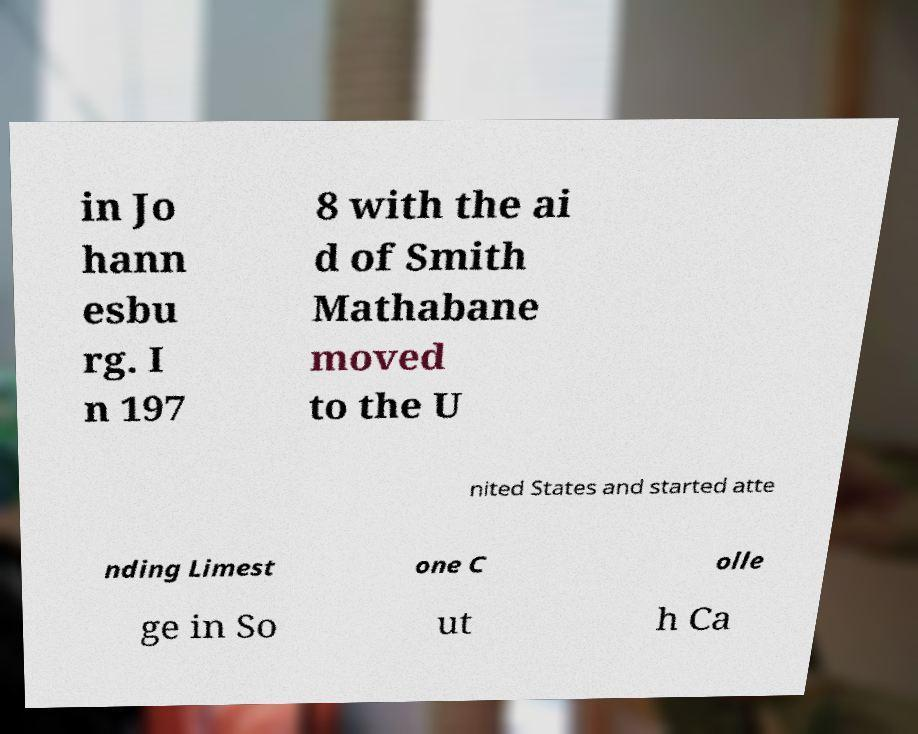Please identify and transcribe the text found in this image. in Jo hann esbu rg. I n 197 8 with the ai d of Smith Mathabane moved to the U nited States and started atte nding Limest one C olle ge in So ut h Ca 